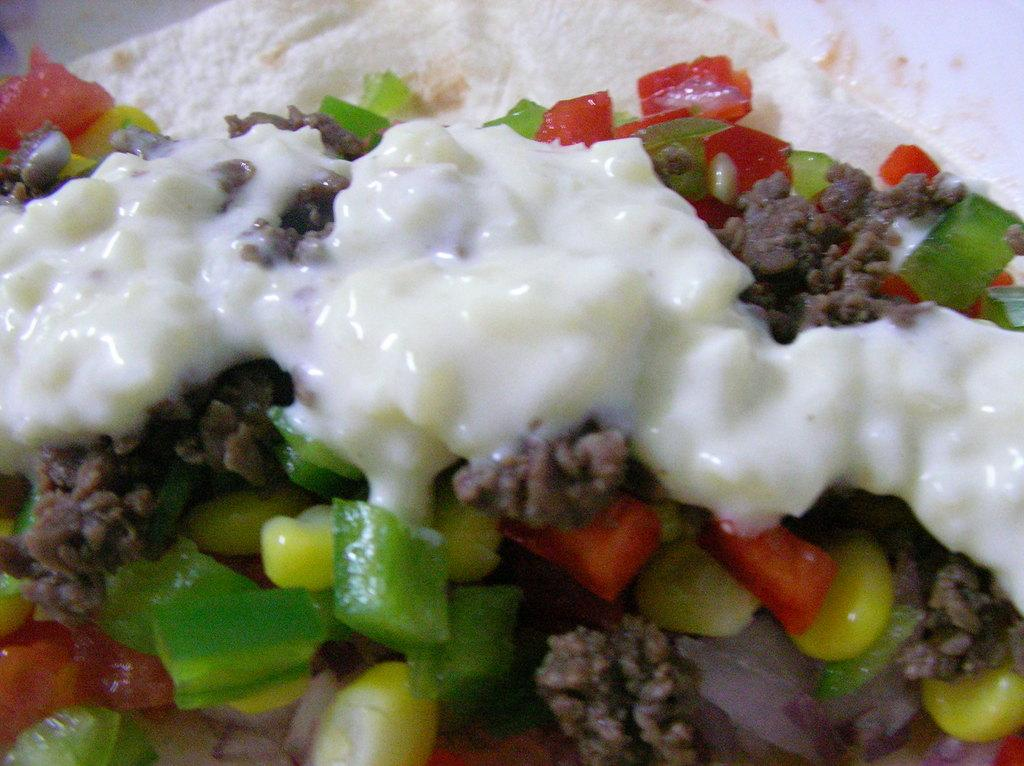What is on the plate in the image? There is food on a plate in the image. What specific ingredients can be identified in the food? The food contains chopped capsicum, sweet corn, and minced meat. What type of mitten is being used to mix the ingredients in the image? There is no mitten present in the image, and the ingredients are not being mixed. 